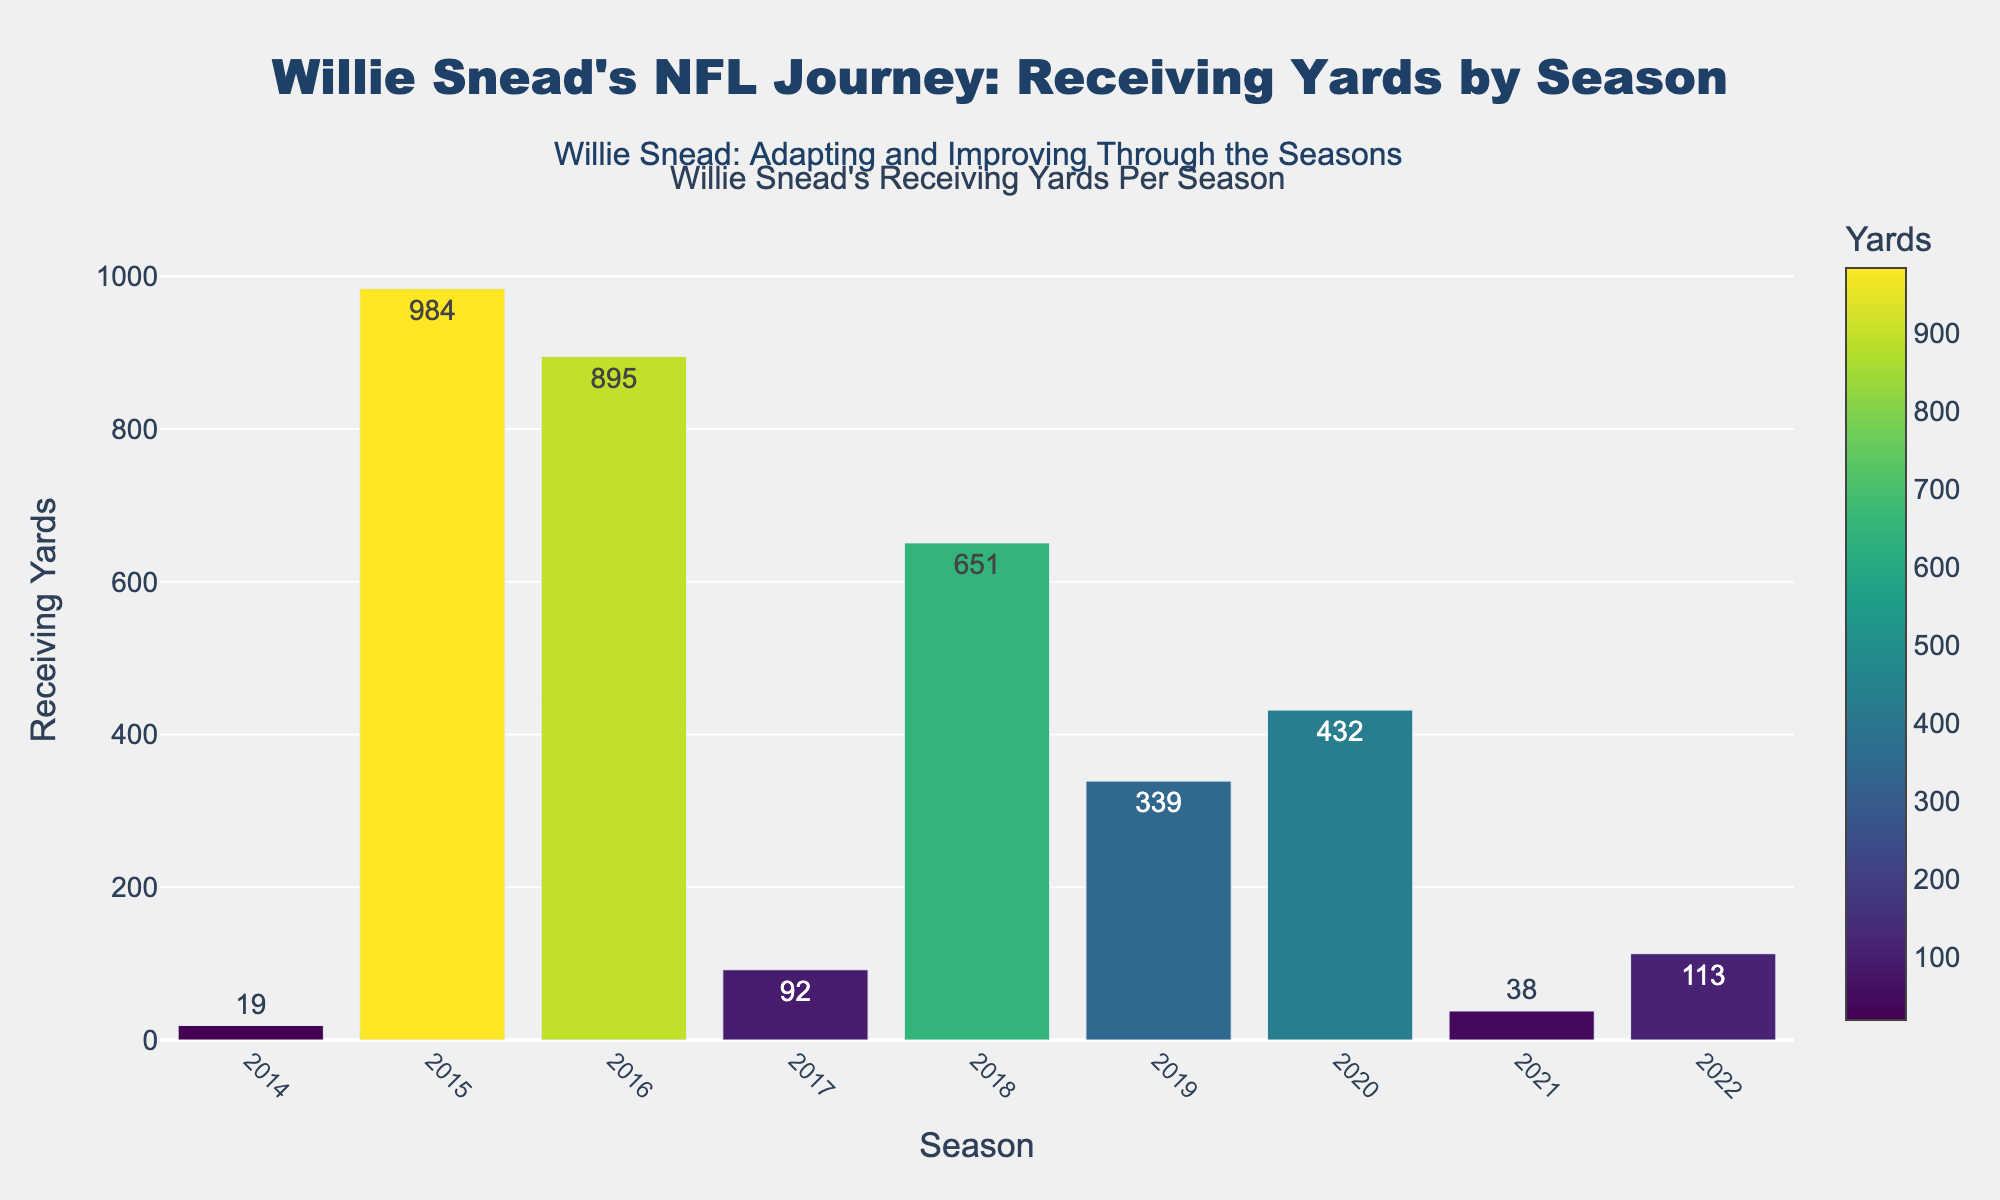Which season had the highest receiving yards for Willie Snead? By looking at the heights of the bars, the 2015 season had the tallest bar, indicating the highest receiving yards.
Answer: 2015 What is the total receiving yards from 2018 to 2020? Adding the values from the 2018, 2019, and 2020 seasons: 651 + 339 + 432 = 1422.
Answer: 1422 In which season did Willie Snead experience the biggest drop in receiving yards compared to the previous year? The largest decrease appears between 2016 (895 yards) and 2017 (92 yards). The difference is 895 - 92 = 803 yards.
Answer: 2017 How many seasons did Willie Snead have over 500 receiving yards? The bars above 500 receiving yards are for the 2015 (984 yards), 2016 (895 yards), and 2018 (651 yards) seasons.
Answer: 3 What is the average receiving yards per season across the entire career span shown? Sum the receiving yards: 19 + 984 + 895 + 92 + 651 + 339 + 432 + 38 + 113 = 3563. There are 9 seasons, so the average is 3563 / 9 = 396.
Answer: 396 Between which two consecutive seasons did Willie Snead see the greatest improvement in receiving yards? The largest increase appears between 2017 (92 yards) and 2018 (651 yards). The difference is 651 - 92 = 559 yards.
Answer: 2017 to 2018 Was there ever a season where Willie Snead had less than 100 receiving yards? Yes, the seasons are 2014 (19 yards), 2017 (92 yards), and 2021 (38 yards).
Answer: Yes Which seasons had receiving yards in a similar range (within 100 yards)? The 2019 (339 yards) and 2020 (432 yards) seasons are within 100 yards of each other.
Answer: 2019 and 2020 What is the median value of receiving yards over the seasons? Arrange the values in ascending order: 19, 38, 92, 113, 339, 432, 651, 895, 984. The median value (the middle value) is 339.
Answer: 339 